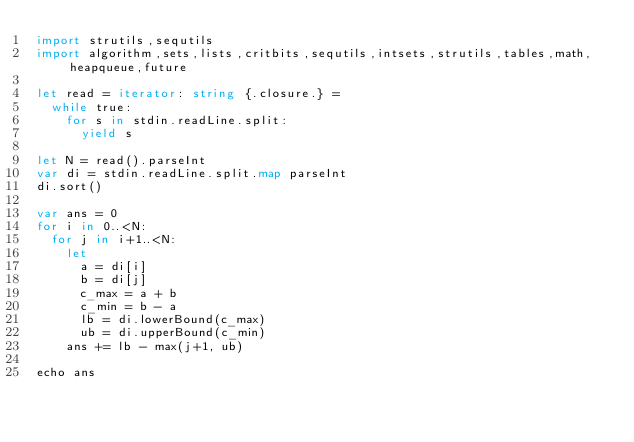Convert code to text. <code><loc_0><loc_0><loc_500><loc_500><_Nim_>import strutils,sequtils
import algorithm,sets,lists,critbits,sequtils,intsets,strutils,tables,math,heapqueue,future

let read = iterator: string {.closure.} =
  while true:
    for s in stdin.readLine.split:
      yield s

let N = read().parseInt
var di = stdin.readLine.split.map parseInt
di.sort()

var ans = 0
for i in 0..<N:
  for j in i+1..<N:
    let
      a = di[i]
      b = di[j]
      c_max = a + b
      c_min = b - a
      lb = di.lowerBound(c_max)
      ub = di.upperBound(c_min)
    ans += lb - max(j+1, ub)

echo ans
</code> 